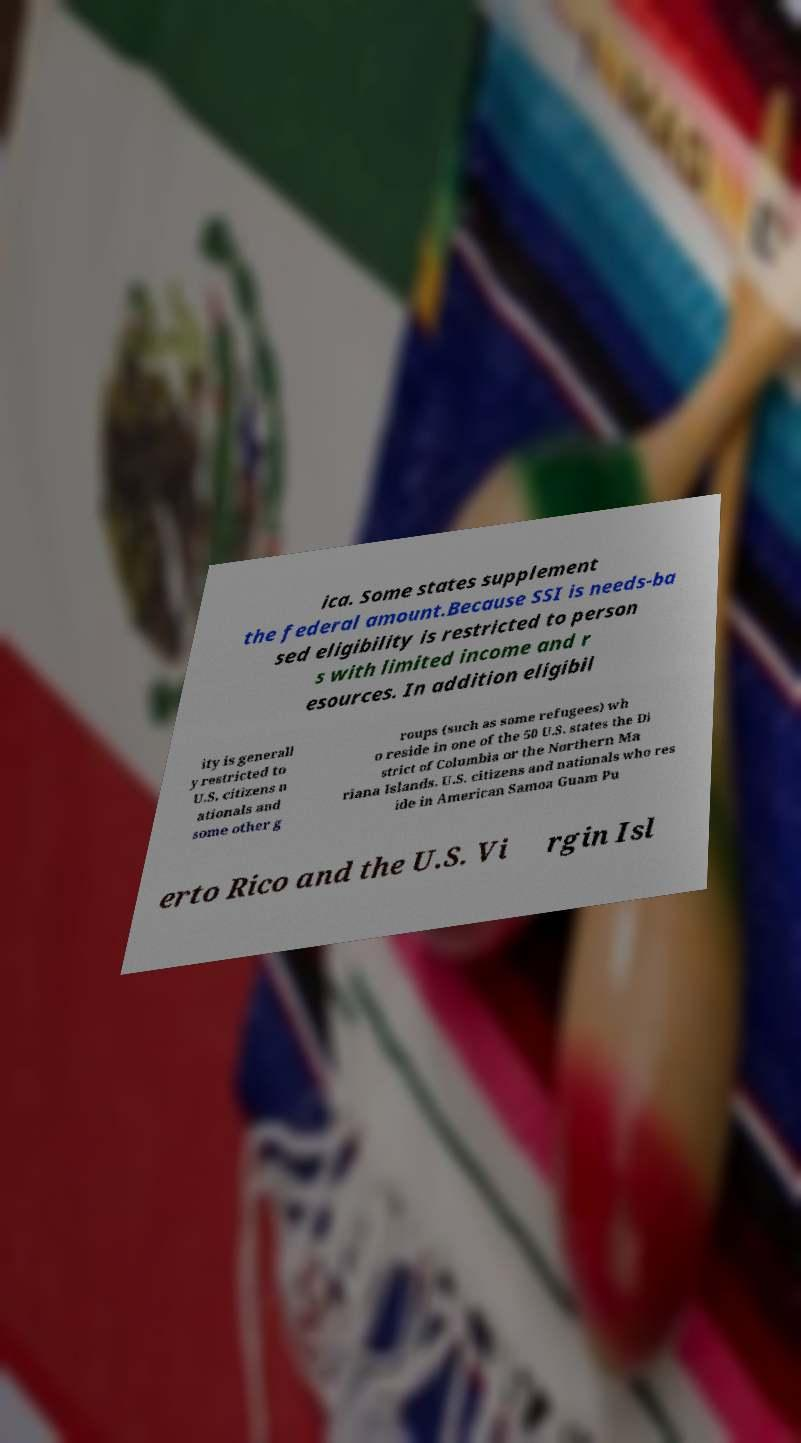What messages or text are displayed in this image? I need them in a readable, typed format. ica. Some states supplement the federal amount.Because SSI is needs-ba sed eligibility is restricted to person s with limited income and r esources. In addition eligibil ity is generall y restricted to U.S. citizens n ationals and some other g roups (such as some refugees) wh o reside in one of the 50 U.S. states the Di strict of Columbia or the Northern Ma riana Islands. U.S. citizens and nationals who res ide in American Samoa Guam Pu erto Rico and the U.S. Vi rgin Isl 